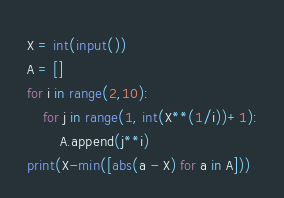Convert code to text. <code><loc_0><loc_0><loc_500><loc_500><_Python_>X = int(input())
A = []
for i in range(2,10):
    for j in range(1, int(X**(1/i))+1):
        A.append(j**i)
print(X-min([abs(a - X) for a in A]))</code> 